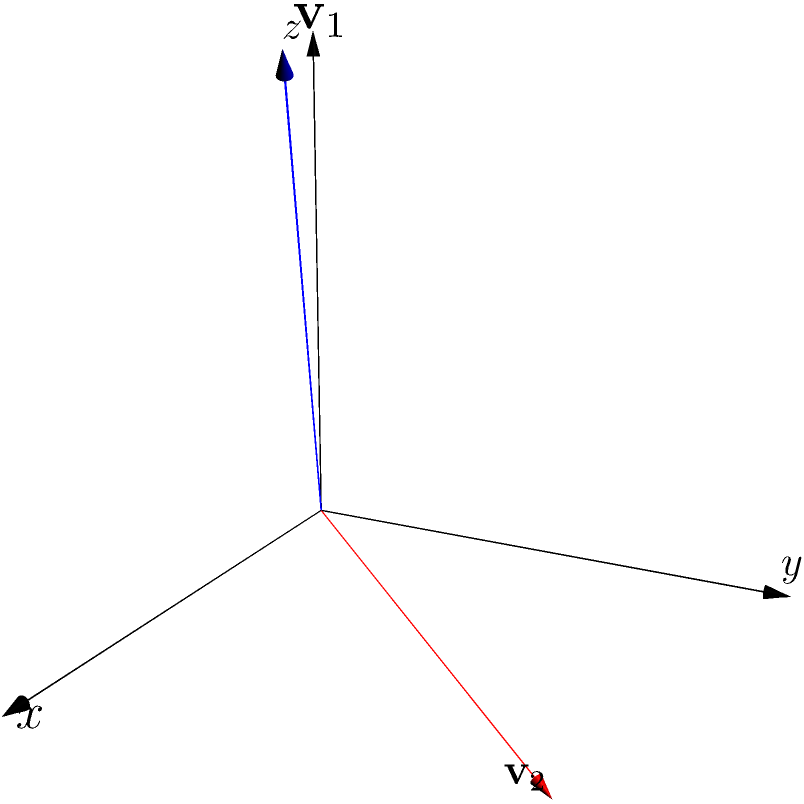In a protein structure analysis, two vectors $\mathbf{v}_1 = (2,1,3)$ and $\mathbf{v}_2 = (1,2,-1)$ represent the spatial orientation of two α-helices. Calculate the cross product $\mathbf{v}_1 \times \mathbf{v}_2$ to determine the vector perpendicular to both α-helices. What is the magnitude of this resulting vector? To solve this problem, we'll follow these steps:

1) First, calculate the cross product $\mathbf{v}_1 \times \mathbf{v}_2$ using the formula:
   $\mathbf{v}_1 \times \mathbf{v}_2 = (y_1z_2 - z_1y_2, z_1x_2 - x_1z_2, x_1y_2 - y_1x_2)$

   Where $\mathbf{v}_1 = (x_1, y_1, z_1)$ and $\mathbf{v}_2 = (x_2, y_2, z_2)$

2) Substituting the values:
   $\mathbf{v}_1 \times \mathbf{v}_2 = ((1)(−1) - (3)(2), (3)(1) - (2)(−1), (2)(2) - (1)(1))$

3) Calculating each component:
   $\mathbf{v}_1 \times \mathbf{v}_2 = (-1 - 6, 3 + 2, 4 - 1) = (-7, 5, 3)$

4) The resulting vector perpendicular to both α-helices is $(-7, 5, 3)$

5) To find the magnitude of this vector, use the formula:
   $|\mathbf{v}| = \sqrt{x^2 + y^2 + z^2}$

6) Substituting the values:
   $|\mathbf{v}| = \sqrt{(-7)^2 + 5^2 + 3^2}$

7) Calculating:
   $|\mathbf{v}| = \sqrt{49 + 25 + 9} = \sqrt{83}$

Therefore, the magnitude of the vector perpendicular to both α-helices is $\sqrt{83}$.
Answer: $\sqrt{83}$ 